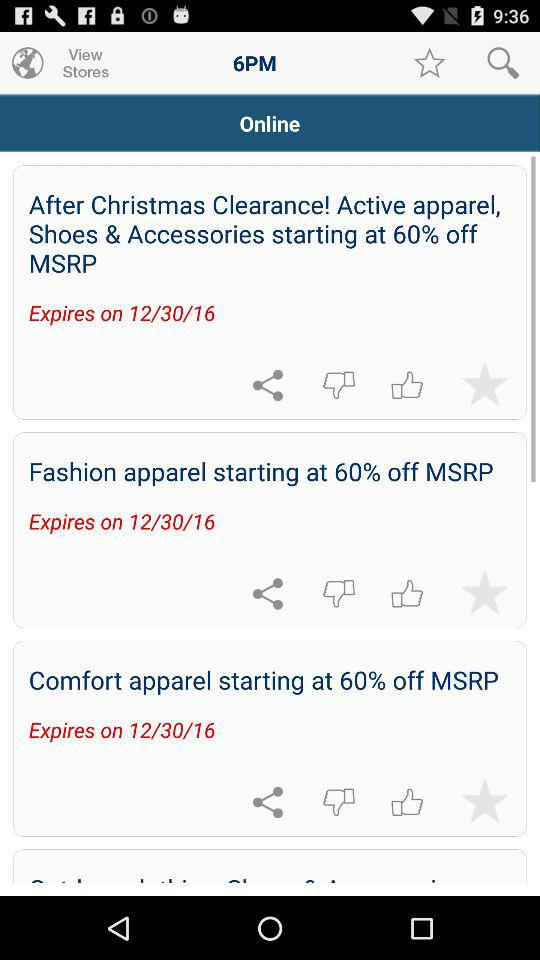What are the given login options? The given login options are "Google", "Facebook" and "Email". 